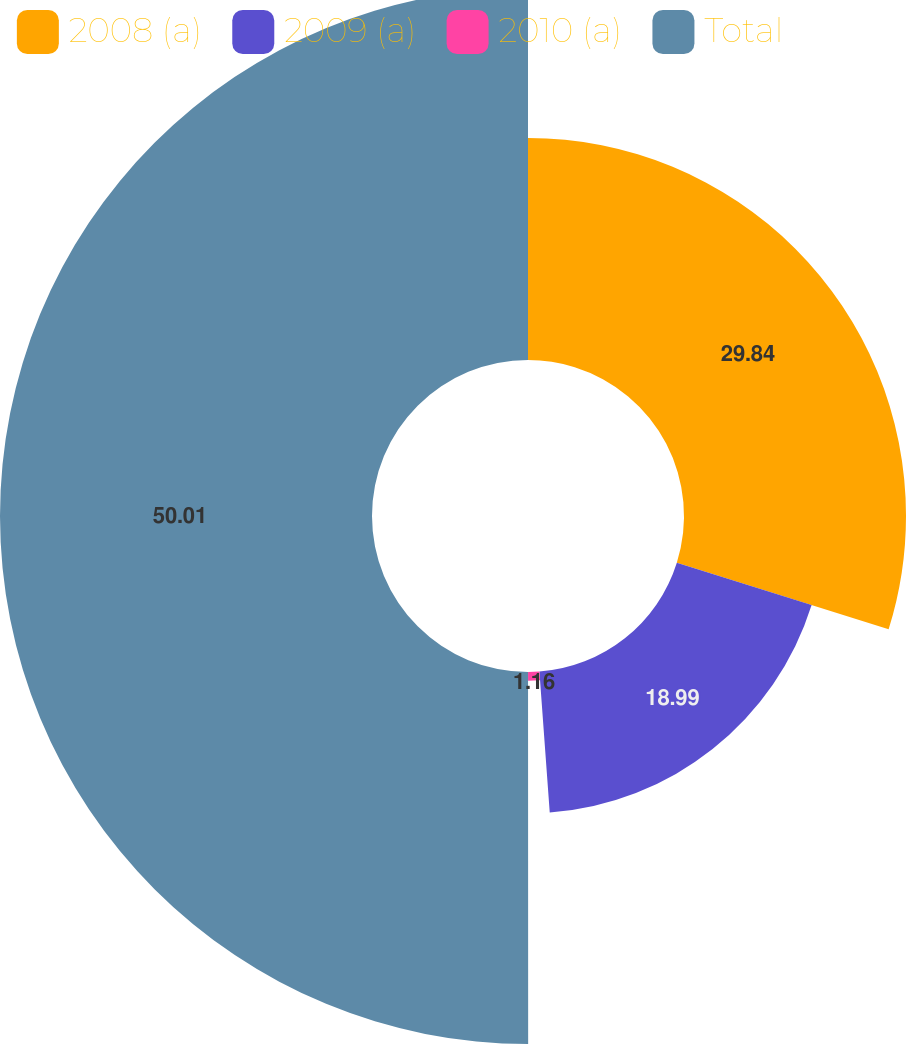Convert chart. <chart><loc_0><loc_0><loc_500><loc_500><pie_chart><fcel>2008 (a)<fcel>2009 (a)<fcel>2010 (a)<fcel>Total<nl><fcel>29.84%<fcel>18.99%<fcel>1.16%<fcel>50.0%<nl></chart> 